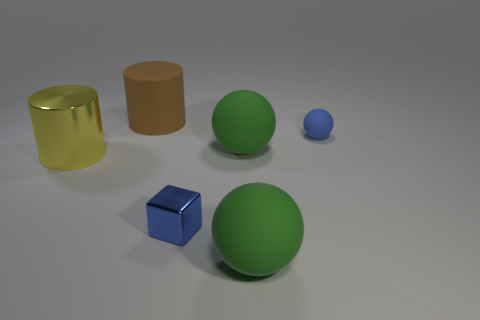How would you assess the composition of the scene in terms of balance and arrangement? The composition seems carefully arranged for visual balance. The objects are spread out across the image, but there's a sense of symmetry with the green spheres central to the scene. This arrangement leads the viewer’s eye throughout the image while maintaining focus on the most significant elements. 